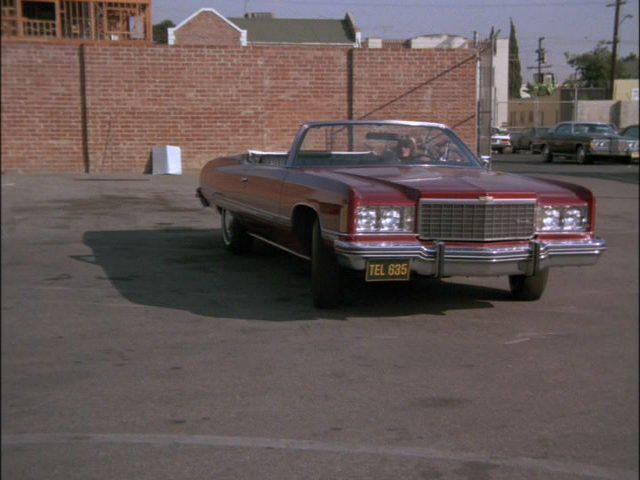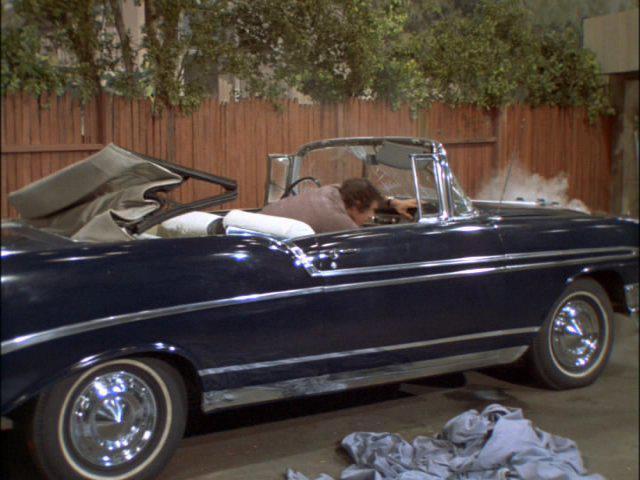The first image is the image on the left, the second image is the image on the right. Given the left and right images, does the statement "The red car on the right is sitting in the driveway." hold true? Answer yes or no. No. 